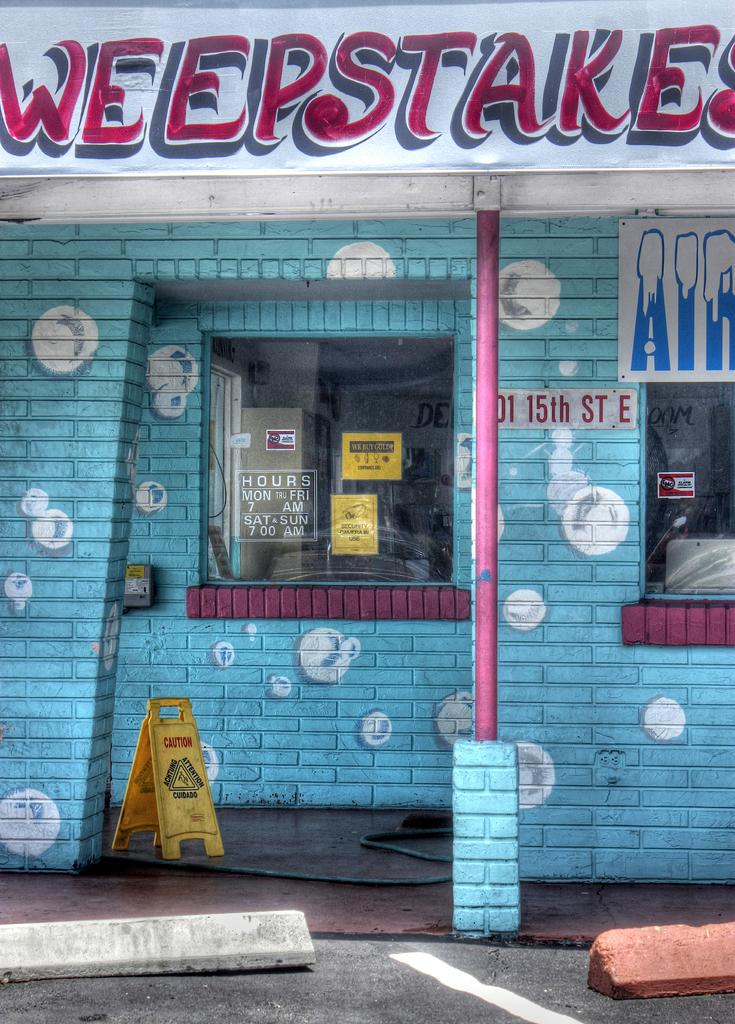What type of building is shown in the image? There is a shop in the image. What material is the shop made of? The shop is made up of bricks. What feature allows people to see inside the shop? The shop has glass windows. What is blocking the entrance or pathway in the image? There is a barricade in the image. What is displayed on the poster in the image? There is a poster in the image, and it has text on it. How much tax is being collected from the shop in the image? There is no information about taxes in the image, so we cannot determine the amount of tax being collected. 